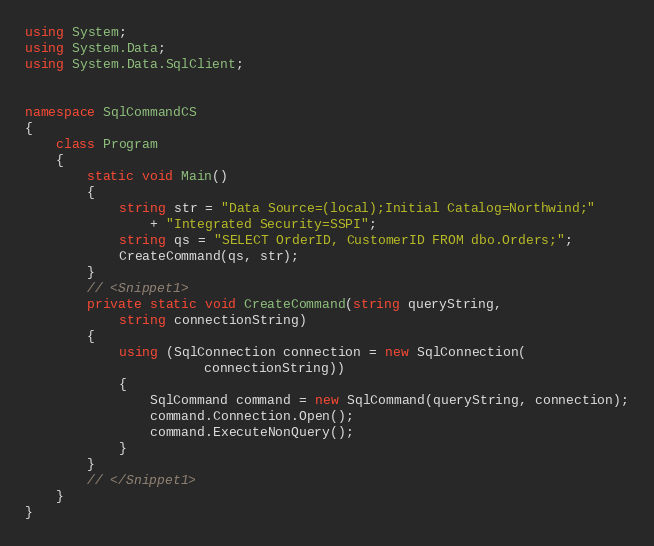<code> <loc_0><loc_0><loc_500><loc_500><_C#_>

using System;
using System.Data;
using System.Data.SqlClient;


namespace SqlCommandCS
{
    class Program
    {
        static void Main()
        {
            string str = "Data Source=(local);Initial Catalog=Northwind;"
                + "Integrated Security=SSPI";
            string qs = "SELECT OrderID, CustomerID FROM dbo.Orders;";
            CreateCommand(qs, str);
        }
        // <Snippet1>
        private static void CreateCommand(string queryString,
            string connectionString)
        {
            using (SqlConnection connection = new SqlConnection(
                       connectionString))
            {
                SqlCommand command = new SqlCommand(queryString, connection);
                command.Connection.Open();
                command.ExecuteNonQuery();
            }
        }
        // </Snippet1>
    }
}
</code> 